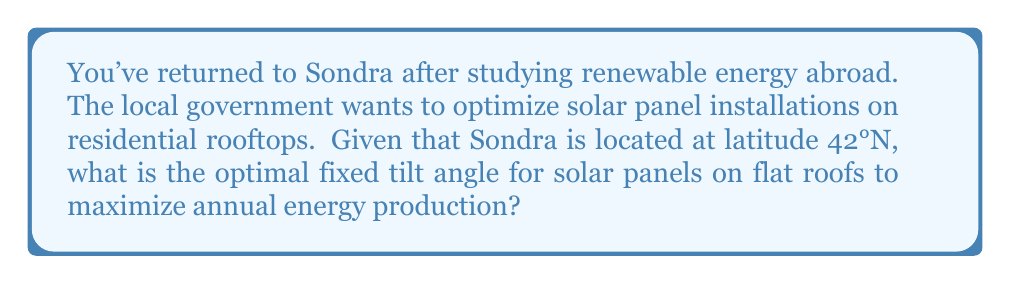Can you answer this question? To determine the optimal tilt angle for solar panels, we need to consider the latitude of the location. A general rule of thumb for fixed solar panels is that the optimal tilt angle is approximately equal to the latitude of the location.

Let's break this down:

1. Sondra's latitude: 42°N

2. The optimal tilt angle formula for fixed panels:
   $$ \text{Optimal Tilt Angle} \approx \text{Latitude} $$

3. Applying the formula:
   $$ \text{Optimal Tilt Angle} \approx 42° $$

This approximation works well for maximizing annual energy production. The reasoning behind this is that the sun's position in the sky changes throughout the year:

- In summer, the sun is higher in the sky
- In winter, the sun is lower in the sky

By setting the tilt angle equal to the latitude, we achieve a balance that optimizes energy production across all seasons.

[asy]
import geometry;

size(200);
draw((-50,0)--(50,0),arrow=Arrow(TeXHead));
draw((0,-10)--(0,50),arrow=Arrow(TeXHead));
draw((0,0)--(35,35),linewidth(1));
draw((-10,0)--(-10,42),dashed);
draw((-10,42)--(0,42),dashed);
label("42°", (-5,20), E);
label("Optimal Tilt Angle", (20,40), NE);
label("Horizontal", (20,-5), S);
</asy]

Note: For more precise calculations, factors such as local climate, weather patterns, and potential obstructions should be considered. Additionally, adjustable systems that can change tilt angle seasonally can further optimize energy production.
Answer: The optimal fixed tilt angle for solar panels in Sondra is approximately 42°. 